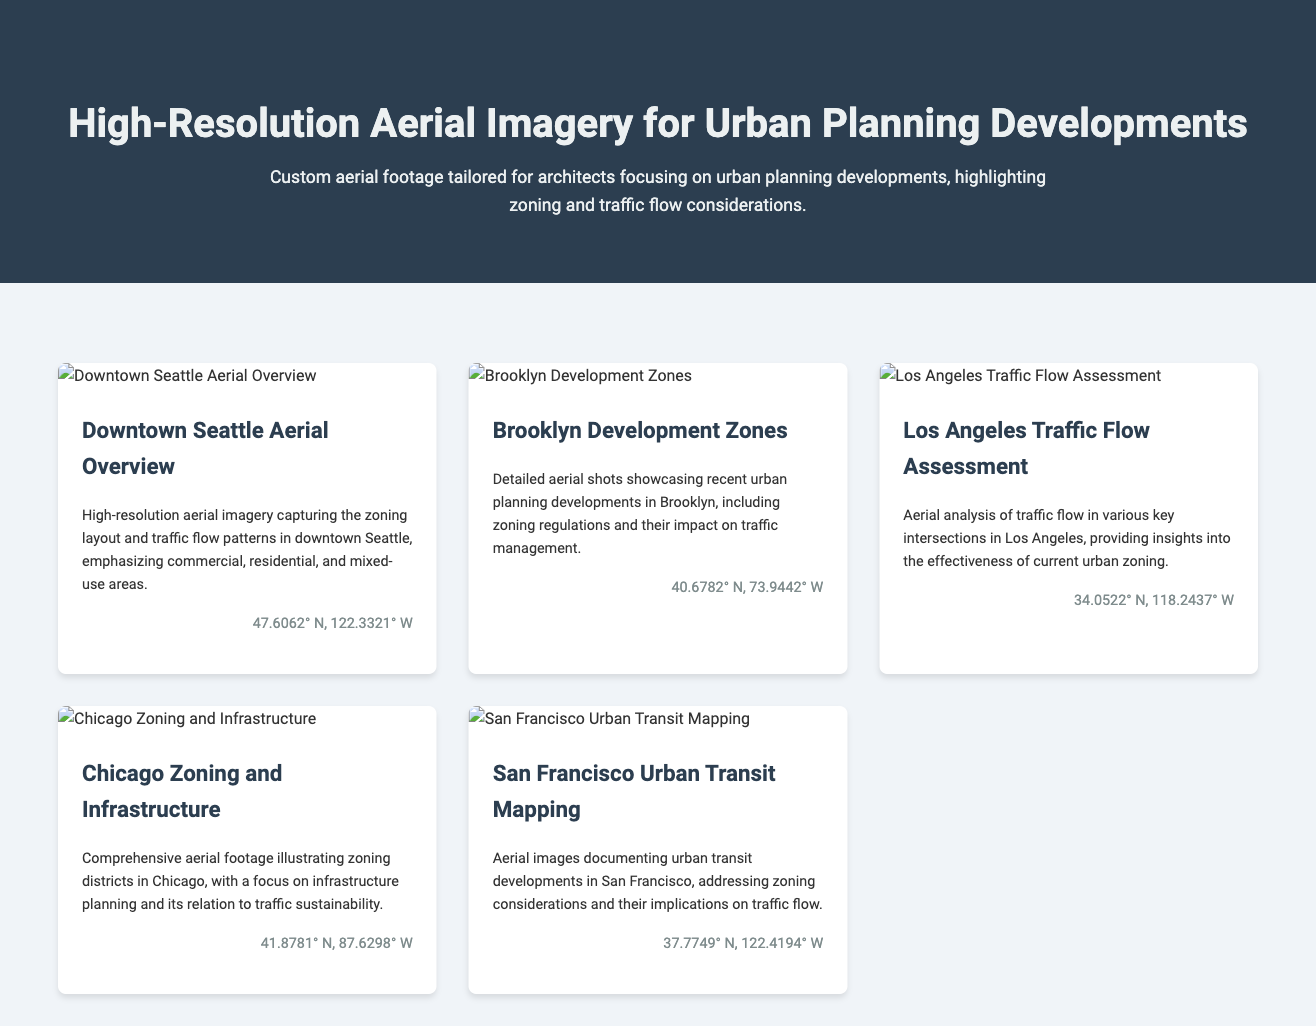What is the title of the document? The title is prominently displayed in the header section of the document.
Answer: High-Resolution Aerial Imagery for Urban Planning Developments How many aerial imagery samples are provided? There are five different aerial imagery samples listed in the materials section of the document.
Answer: Five What city is covered in the aerial overview image? The city name is mentioned in the title of the aerial imagery sample about the overview.
Answer: Seattle What coordinates are associated with the Brooklyn aerial imagery? The coordinates are included in the specific aerial sample's footer as geographic information.
Answer: 40.6782° N, 73.9442° W Which aerial imagery focuses on traffic flow assessment? The focus is identified in the title of the relevant aerial imagery sample regarding traffic flow.
Answer: Los Angeles Traffic Flow Assessment What type of zoning is emphasized in the Chicago footage? The nature of zoning focus is indicated in the descriptive text of the aerial sample.
Answer: Zoning districts Which city’s urban transit developments are documented? The city name is specifically stated in the title of the respective aerial imagery.
Answer: San Francisco What is highlighted in the Downtown Seattle aerial imagery? The focus areas are detailed in the description of the aerial imagery provided for Seattle.
Answer: Zoning layout and traffic flow patterns Which image showcases recent developments in Brooklyn? The identifier is found in the title of the corresponding imagery sample.
Answer: Brooklyn Development Zones 